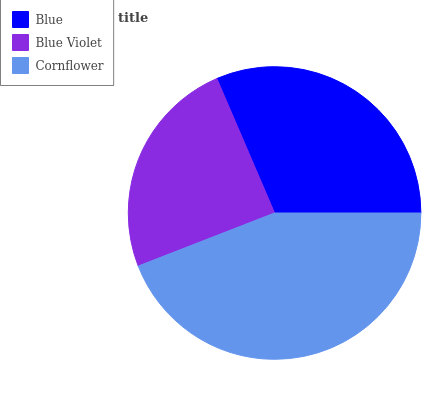Is Blue Violet the minimum?
Answer yes or no. Yes. Is Cornflower the maximum?
Answer yes or no. Yes. Is Cornflower the minimum?
Answer yes or no. No. Is Blue Violet the maximum?
Answer yes or no. No. Is Cornflower greater than Blue Violet?
Answer yes or no. Yes. Is Blue Violet less than Cornflower?
Answer yes or no. Yes. Is Blue Violet greater than Cornflower?
Answer yes or no. No. Is Cornflower less than Blue Violet?
Answer yes or no. No. Is Blue the high median?
Answer yes or no. Yes. Is Blue the low median?
Answer yes or no. Yes. Is Blue Violet the high median?
Answer yes or no. No. Is Blue Violet the low median?
Answer yes or no. No. 